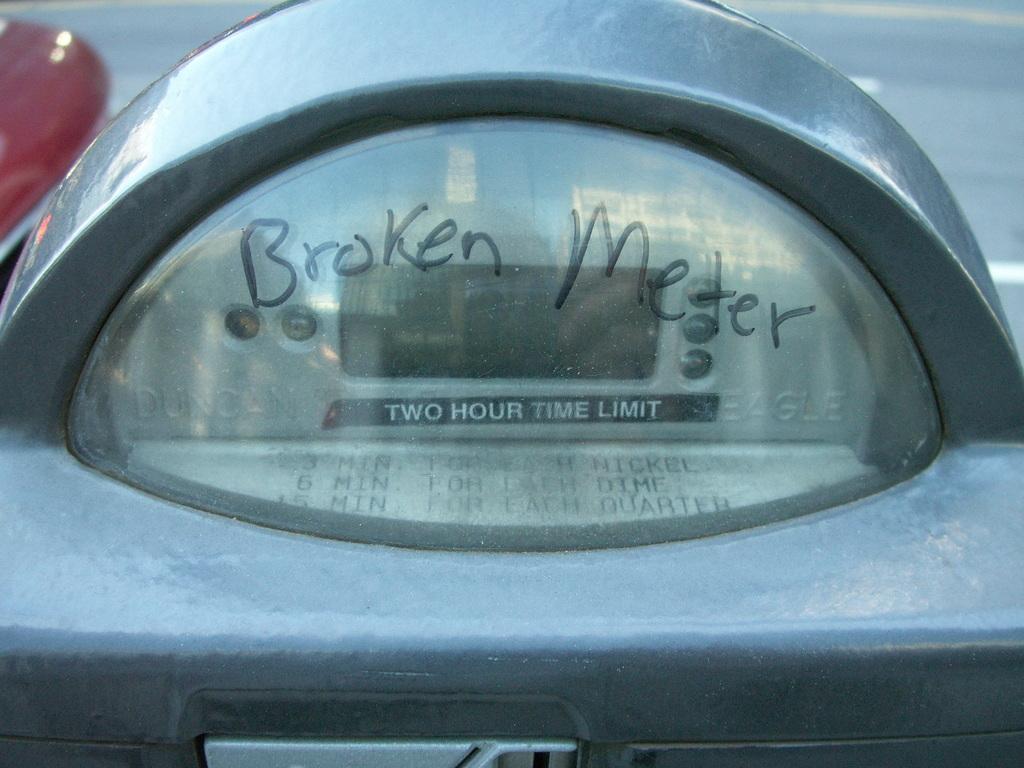What is this a picture of?
Your response must be concise. Broken meter. What is wrong?
Give a very brief answer. Broken meter. 